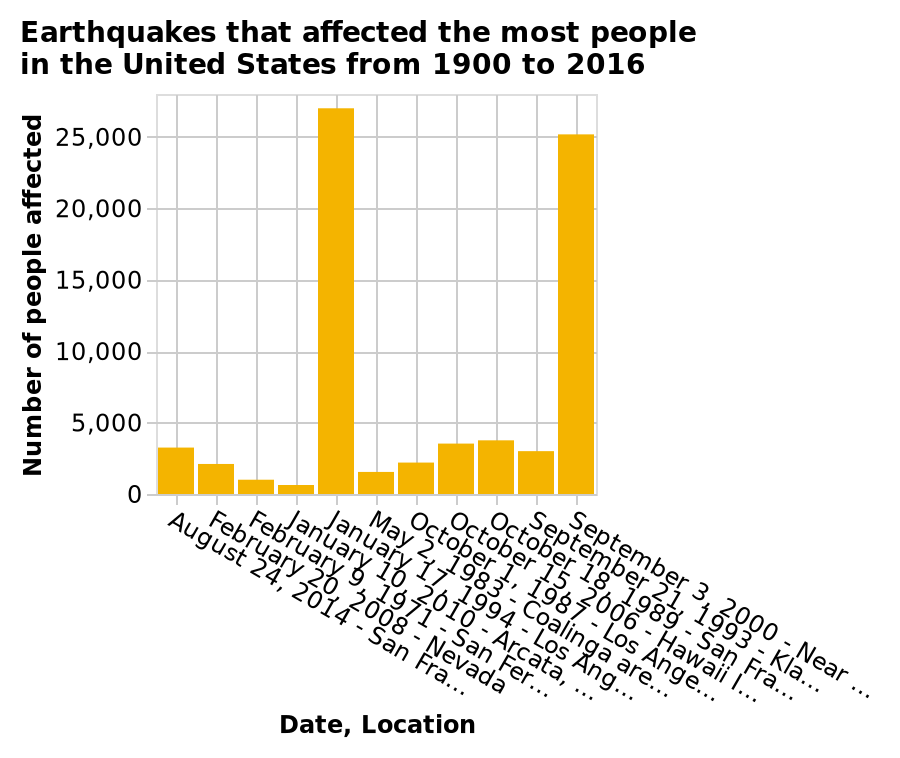<image>
please describe the details of the chart Here a is a bar chart called Earthquakes that affected the most people in the United States from 1900 to 2016. The x-axis plots Date, Location. On the y-axis, Number of people affected is drawn along a linear scale of range 0 to 25,000. What is displayed on the y-axis of the bar chart? The y-axis of the bar chart displays the Number of people affected. Are most earthquakes concentrated on the west coast?  Yes, most earthquakes have occurred on the west coast. What is plotted on the x-axis of the bar chart?  The x-axis of the bar chart plots the Date and Location. How many people are typically affected by an earthquake?  Typically, the number of people affected by an earthquake is below 5,000. Does the x-axis of the bar chart plot the Time and Place? No. The x-axis of the bar chart plots the Date and Location. 